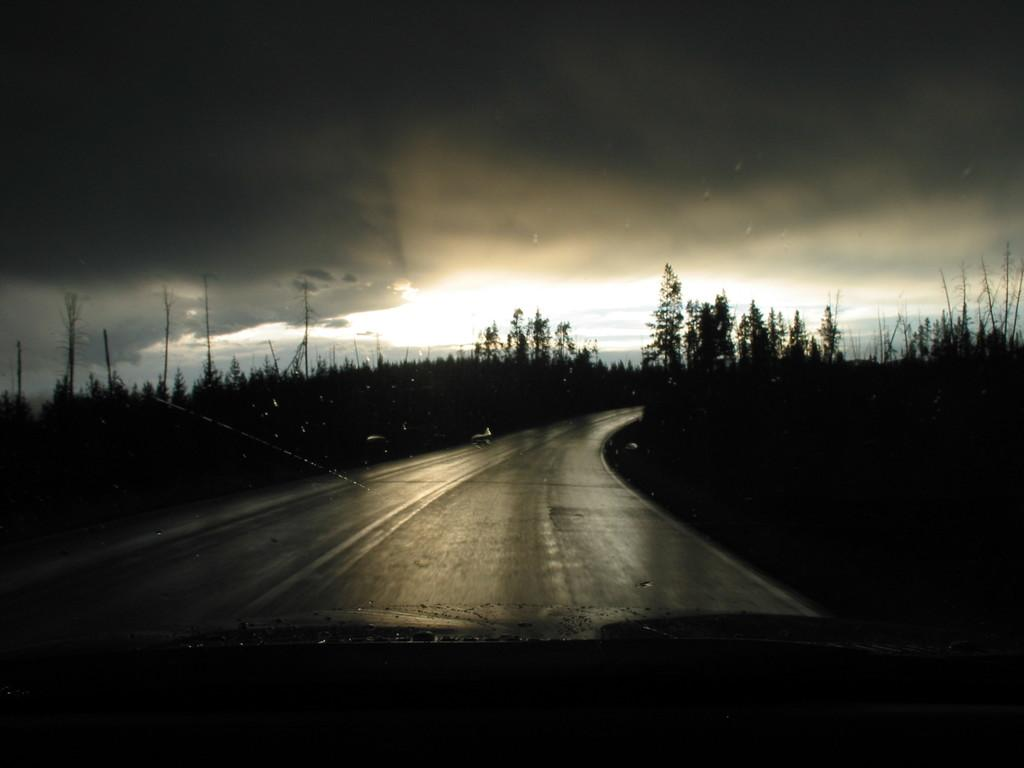What is one of the main elements visible in the image? The sky is one of the main elements visible in the image. What can be seen in the sky in the image? Clouds are present in the image. What type of natural vegetation is visible in the image? Trees are visible in the image. What type of man-made structures are present in the image? Poles are present in the image. What type of man-made pathway is visible in the image? A road is visible in the image. What type of haircut does the basketball have in the image? There is no basketball present in the image, so it is not possible to answer that question. 